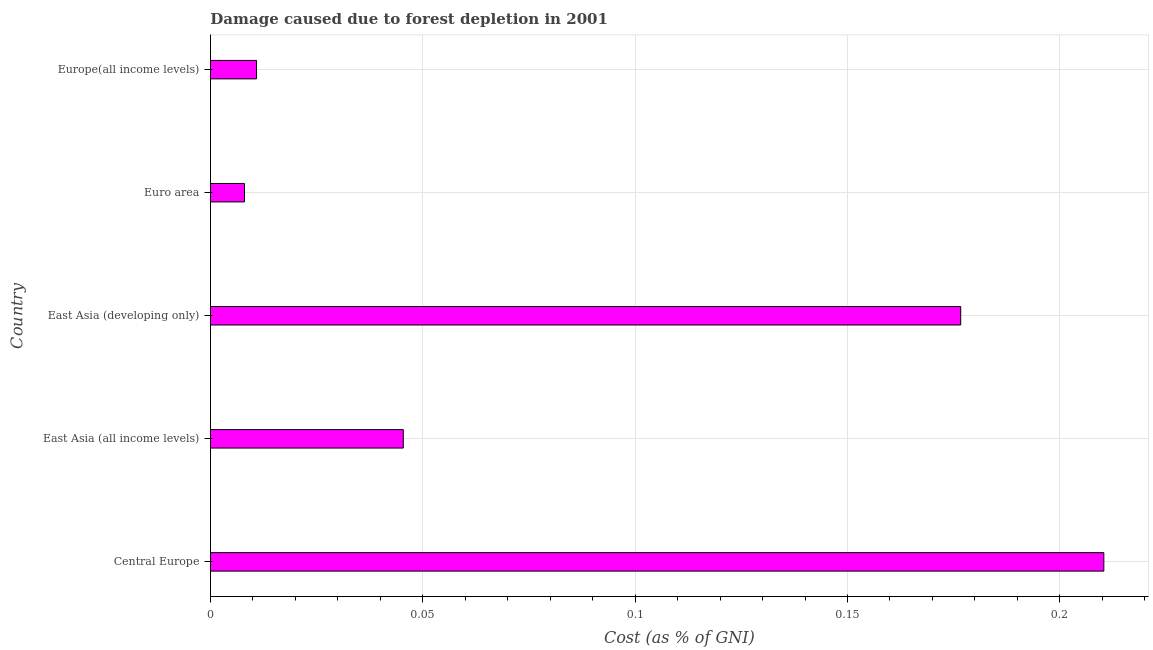Does the graph contain grids?
Provide a short and direct response. Yes. What is the title of the graph?
Your answer should be very brief. Damage caused due to forest depletion in 2001. What is the label or title of the X-axis?
Keep it short and to the point. Cost (as % of GNI). What is the label or title of the Y-axis?
Provide a succinct answer. Country. What is the damage caused due to forest depletion in Euro area?
Provide a succinct answer. 0.01. Across all countries, what is the maximum damage caused due to forest depletion?
Make the answer very short. 0.21. Across all countries, what is the minimum damage caused due to forest depletion?
Your answer should be compact. 0.01. In which country was the damage caused due to forest depletion maximum?
Ensure brevity in your answer.  Central Europe. In which country was the damage caused due to forest depletion minimum?
Provide a succinct answer. Euro area. What is the sum of the damage caused due to forest depletion?
Your answer should be very brief. 0.45. What is the difference between the damage caused due to forest depletion in Central Europe and East Asia (developing only)?
Give a very brief answer. 0.03. What is the average damage caused due to forest depletion per country?
Your answer should be very brief. 0.09. What is the median damage caused due to forest depletion?
Your response must be concise. 0.05. What is the ratio of the damage caused due to forest depletion in East Asia (developing only) to that in Euro area?
Provide a succinct answer. 22.04. Is the damage caused due to forest depletion in Central Europe less than that in Europe(all income levels)?
Ensure brevity in your answer.  No. Is the difference between the damage caused due to forest depletion in East Asia (developing only) and Euro area greater than the difference between any two countries?
Your response must be concise. No. What is the difference between the highest and the second highest damage caused due to forest depletion?
Ensure brevity in your answer.  0.03. Is the sum of the damage caused due to forest depletion in East Asia (all income levels) and Euro area greater than the maximum damage caused due to forest depletion across all countries?
Provide a succinct answer. No. What is the difference between the highest and the lowest damage caused due to forest depletion?
Give a very brief answer. 0.2. In how many countries, is the damage caused due to forest depletion greater than the average damage caused due to forest depletion taken over all countries?
Give a very brief answer. 2. How many bars are there?
Your answer should be compact. 5. How many countries are there in the graph?
Your answer should be very brief. 5. What is the difference between two consecutive major ticks on the X-axis?
Keep it short and to the point. 0.05. Are the values on the major ticks of X-axis written in scientific E-notation?
Provide a succinct answer. No. What is the Cost (as % of GNI) of Central Europe?
Give a very brief answer. 0.21. What is the Cost (as % of GNI) in East Asia (all income levels)?
Provide a short and direct response. 0.05. What is the Cost (as % of GNI) in East Asia (developing only)?
Give a very brief answer. 0.18. What is the Cost (as % of GNI) of Euro area?
Your answer should be compact. 0.01. What is the Cost (as % of GNI) in Europe(all income levels)?
Offer a terse response. 0.01. What is the difference between the Cost (as % of GNI) in Central Europe and East Asia (all income levels)?
Offer a terse response. 0.16. What is the difference between the Cost (as % of GNI) in Central Europe and East Asia (developing only)?
Make the answer very short. 0.03. What is the difference between the Cost (as % of GNI) in Central Europe and Euro area?
Your answer should be compact. 0.2. What is the difference between the Cost (as % of GNI) in Central Europe and Europe(all income levels)?
Provide a succinct answer. 0.2. What is the difference between the Cost (as % of GNI) in East Asia (all income levels) and East Asia (developing only)?
Provide a succinct answer. -0.13. What is the difference between the Cost (as % of GNI) in East Asia (all income levels) and Euro area?
Give a very brief answer. 0.04. What is the difference between the Cost (as % of GNI) in East Asia (all income levels) and Europe(all income levels)?
Your response must be concise. 0.03. What is the difference between the Cost (as % of GNI) in East Asia (developing only) and Euro area?
Ensure brevity in your answer.  0.17. What is the difference between the Cost (as % of GNI) in East Asia (developing only) and Europe(all income levels)?
Provide a short and direct response. 0.17. What is the difference between the Cost (as % of GNI) in Euro area and Europe(all income levels)?
Make the answer very short. -0. What is the ratio of the Cost (as % of GNI) in Central Europe to that in East Asia (all income levels)?
Offer a terse response. 4.63. What is the ratio of the Cost (as % of GNI) in Central Europe to that in East Asia (developing only)?
Give a very brief answer. 1.19. What is the ratio of the Cost (as % of GNI) in Central Europe to that in Euro area?
Provide a short and direct response. 26.25. What is the ratio of the Cost (as % of GNI) in Central Europe to that in Europe(all income levels)?
Keep it short and to the point. 19.4. What is the ratio of the Cost (as % of GNI) in East Asia (all income levels) to that in East Asia (developing only)?
Your answer should be very brief. 0.26. What is the ratio of the Cost (as % of GNI) in East Asia (all income levels) to that in Euro area?
Your answer should be compact. 5.67. What is the ratio of the Cost (as % of GNI) in East Asia (all income levels) to that in Europe(all income levels)?
Keep it short and to the point. 4.19. What is the ratio of the Cost (as % of GNI) in East Asia (developing only) to that in Euro area?
Give a very brief answer. 22.04. What is the ratio of the Cost (as % of GNI) in East Asia (developing only) to that in Europe(all income levels)?
Ensure brevity in your answer.  16.29. What is the ratio of the Cost (as % of GNI) in Euro area to that in Europe(all income levels)?
Ensure brevity in your answer.  0.74. 